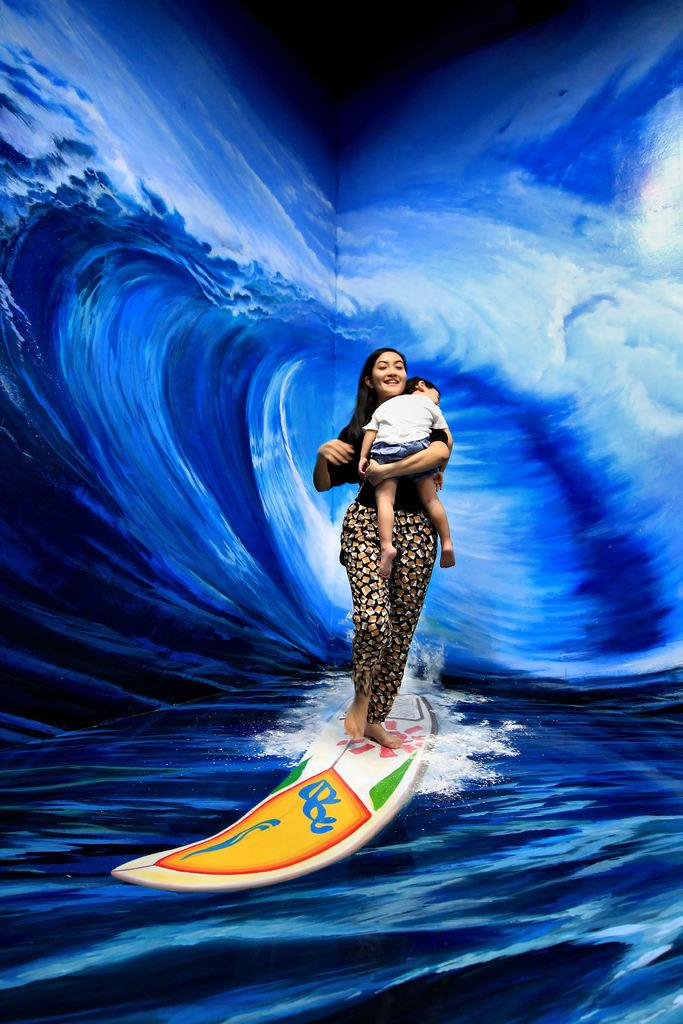What can be observed about the image itself? The image appears to be edited. What can be seen in the background of the image? There is a painting on the wall in the background. Who or what is present in the image? There are people in the image. What is located in the foreground of the image? There is an object in the foreground. What type of flower can be seen growing out of the person's mouth in the image? There is no flower growing out of anyone's mouth in the image; this is not a detail present in the scene. 